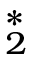<formula> <loc_0><loc_0><loc_500><loc_500>^ { \ast } _ { 2 }</formula> 